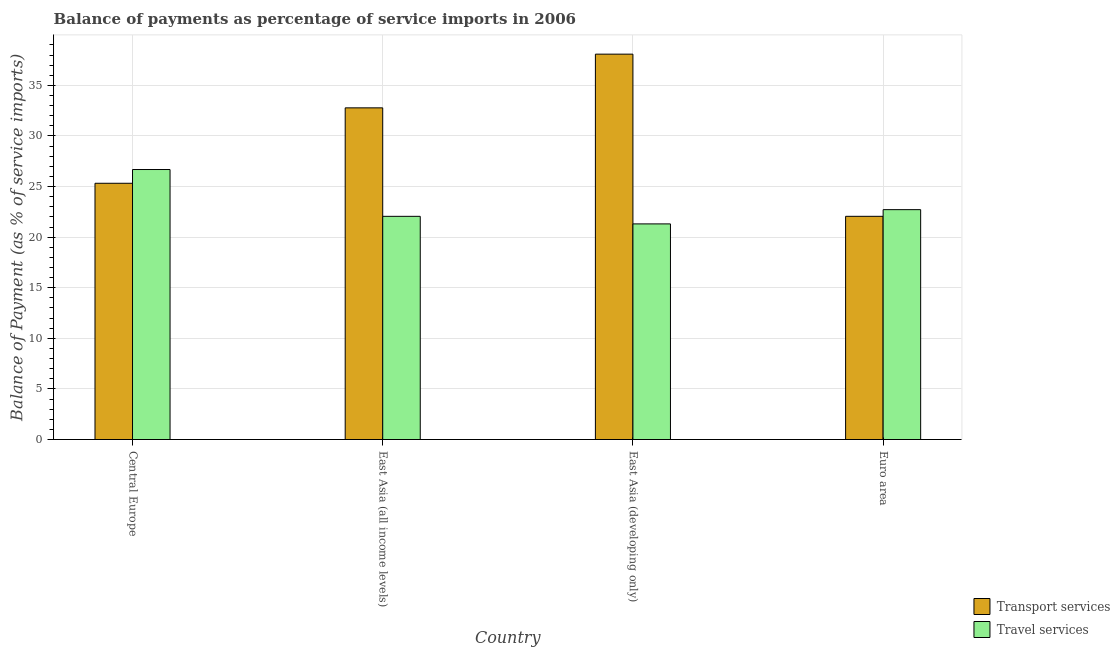Are the number of bars on each tick of the X-axis equal?
Give a very brief answer. Yes. How many bars are there on the 1st tick from the right?
Your answer should be compact. 2. What is the label of the 4th group of bars from the left?
Give a very brief answer. Euro area. In how many cases, is the number of bars for a given country not equal to the number of legend labels?
Offer a terse response. 0. What is the balance of payments of travel services in East Asia (all income levels)?
Give a very brief answer. 22.06. Across all countries, what is the maximum balance of payments of transport services?
Give a very brief answer. 38.09. Across all countries, what is the minimum balance of payments of travel services?
Offer a terse response. 21.31. In which country was the balance of payments of transport services maximum?
Provide a succinct answer. East Asia (developing only). In which country was the balance of payments of travel services minimum?
Ensure brevity in your answer.  East Asia (developing only). What is the total balance of payments of travel services in the graph?
Make the answer very short. 92.77. What is the difference between the balance of payments of transport services in Central Europe and that in Euro area?
Provide a short and direct response. 3.27. What is the difference between the balance of payments of travel services in Euro area and the balance of payments of transport services in Central Europe?
Provide a succinct answer. -2.61. What is the average balance of payments of transport services per country?
Give a very brief answer. 29.56. What is the difference between the balance of payments of transport services and balance of payments of travel services in East Asia (all income levels)?
Your response must be concise. 10.72. What is the ratio of the balance of payments of transport services in Central Europe to that in East Asia (all income levels)?
Give a very brief answer. 0.77. What is the difference between the highest and the second highest balance of payments of transport services?
Give a very brief answer. 5.31. What is the difference between the highest and the lowest balance of payments of transport services?
Keep it short and to the point. 16.03. What does the 2nd bar from the left in East Asia (all income levels) represents?
Make the answer very short. Travel services. What does the 1st bar from the right in East Asia (developing only) represents?
Provide a succinct answer. Travel services. How many bars are there?
Give a very brief answer. 8. How many countries are there in the graph?
Make the answer very short. 4. What is the difference between two consecutive major ticks on the Y-axis?
Keep it short and to the point. 5. How many legend labels are there?
Provide a succinct answer. 2. What is the title of the graph?
Your response must be concise. Balance of payments as percentage of service imports in 2006. Does "Exports" appear as one of the legend labels in the graph?
Your answer should be very brief. No. What is the label or title of the Y-axis?
Make the answer very short. Balance of Payment (as % of service imports). What is the Balance of Payment (as % of service imports) in Transport services in Central Europe?
Your answer should be compact. 25.33. What is the Balance of Payment (as % of service imports) in Travel services in Central Europe?
Your answer should be compact. 26.69. What is the Balance of Payment (as % of service imports) in Transport services in East Asia (all income levels)?
Provide a succinct answer. 32.78. What is the Balance of Payment (as % of service imports) of Travel services in East Asia (all income levels)?
Keep it short and to the point. 22.06. What is the Balance of Payment (as % of service imports) in Transport services in East Asia (developing only)?
Your response must be concise. 38.09. What is the Balance of Payment (as % of service imports) of Travel services in East Asia (developing only)?
Your answer should be very brief. 21.31. What is the Balance of Payment (as % of service imports) of Transport services in Euro area?
Your answer should be very brief. 22.06. What is the Balance of Payment (as % of service imports) in Travel services in Euro area?
Your response must be concise. 22.72. Across all countries, what is the maximum Balance of Payment (as % of service imports) of Transport services?
Your answer should be very brief. 38.09. Across all countries, what is the maximum Balance of Payment (as % of service imports) in Travel services?
Provide a short and direct response. 26.69. Across all countries, what is the minimum Balance of Payment (as % of service imports) of Transport services?
Your answer should be very brief. 22.06. Across all countries, what is the minimum Balance of Payment (as % of service imports) in Travel services?
Your response must be concise. 21.31. What is the total Balance of Payment (as % of service imports) in Transport services in the graph?
Keep it short and to the point. 118.25. What is the total Balance of Payment (as % of service imports) in Travel services in the graph?
Provide a short and direct response. 92.77. What is the difference between the Balance of Payment (as % of service imports) of Transport services in Central Europe and that in East Asia (all income levels)?
Offer a very short reply. -7.45. What is the difference between the Balance of Payment (as % of service imports) of Travel services in Central Europe and that in East Asia (all income levels)?
Your response must be concise. 4.63. What is the difference between the Balance of Payment (as % of service imports) of Transport services in Central Europe and that in East Asia (developing only)?
Keep it short and to the point. -12.76. What is the difference between the Balance of Payment (as % of service imports) in Travel services in Central Europe and that in East Asia (developing only)?
Give a very brief answer. 5.38. What is the difference between the Balance of Payment (as % of service imports) of Transport services in Central Europe and that in Euro area?
Your answer should be very brief. 3.27. What is the difference between the Balance of Payment (as % of service imports) of Travel services in Central Europe and that in Euro area?
Make the answer very short. 3.97. What is the difference between the Balance of Payment (as % of service imports) of Transport services in East Asia (all income levels) and that in East Asia (developing only)?
Offer a very short reply. -5.31. What is the difference between the Balance of Payment (as % of service imports) of Travel services in East Asia (all income levels) and that in East Asia (developing only)?
Keep it short and to the point. 0.75. What is the difference between the Balance of Payment (as % of service imports) of Transport services in East Asia (all income levels) and that in Euro area?
Keep it short and to the point. 10.72. What is the difference between the Balance of Payment (as % of service imports) in Travel services in East Asia (all income levels) and that in Euro area?
Your answer should be compact. -0.66. What is the difference between the Balance of Payment (as % of service imports) in Transport services in East Asia (developing only) and that in Euro area?
Your answer should be compact. 16.03. What is the difference between the Balance of Payment (as % of service imports) in Travel services in East Asia (developing only) and that in Euro area?
Give a very brief answer. -1.41. What is the difference between the Balance of Payment (as % of service imports) of Transport services in Central Europe and the Balance of Payment (as % of service imports) of Travel services in East Asia (all income levels)?
Give a very brief answer. 3.27. What is the difference between the Balance of Payment (as % of service imports) of Transport services in Central Europe and the Balance of Payment (as % of service imports) of Travel services in East Asia (developing only)?
Your answer should be compact. 4.02. What is the difference between the Balance of Payment (as % of service imports) in Transport services in Central Europe and the Balance of Payment (as % of service imports) in Travel services in Euro area?
Your answer should be compact. 2.61. What is the difference between the Balance of Payment (as % of service imports) of Transport services in East Asia (all income levels) and the Balance of Payment (as % of service imports) of Travel services in East Asia (developing only)?
Give a very brief answer. 11.47. What is the difference between the Balance of Payment (as % of service imports) in Transport services in East Asia (all income levels) and the Balance of Payment (as % of service imports) in Travel services in Euro area?
Provide a short and direct response. 10.06. What is the difference between the Balance of Payment (as % of service imports) in Transport services in East Asia (developing only) and the Balance of Payment (as % of service imports) in Travel services in Euro area?
Give a very brief answer. 15.37. What is the average Balance of Payment (as % of service imports) of Transport services per country?
Provide a short and direct response. 29.56. What is the average Balance of Payment (as % of service imports) of Travel services per country?
Your answer should be compact. 23.19. What is the difference between the Balance of Payment (as % of service imports) of Transport services and Balance of Payment (as % of service imports) of Travel services in Central Europe?
Keep it short and to the point. -1.36. What is the difference between the Balance of Payment (as % of service imports) in Transport services and Balance of Payment (as % of service imports) in Travel services in East Asia (all income levels)?
Provide a short and direct response. 10.72. What is the difference between the Balance of Payment (as % of service imports) in Transport services and Balance of Payment (as % of service imports) in Travel services in East Asia (developing only)?
Ensure brevity in your answer.  16.78. What is the difference between the Balance of Payment (as % of service imports) of Transport services and Balance of Payment (as % of service imports) of Travel services in Euro area?
Your answer should be very brief. -0.66. What is the ratio of the Balance of Payment (as % of service imports) in Transport services in Central Europe to that in East Asia (all income levels)?
Your answer should be very brief. 0.77. What is the ratio of the Balance of Payment (as % of service imports) of Travel services in Central Europe to that in East Asia (all income levels)?
Your answer should be compact. 1.21. What is the ratio of the Balance of Payment (as % of service imports) in Transport services in Central Europe to that in East Asia (developing only)?
Provide a succinct answer. 0.66. What is the ratio of the Balance of Payment (as % of service imports) in Travel services in Central Europe to that in East Asia (developing only)?
Your answer should be compact. 1.25. What is the ratio of the Balance of Payment (as % of service imports) of Transport services in Central Europe to that in Euro area?
Your answer should be compact. 1.15. What is the ratio of the Balance of Payment (as % of service imports) of Travel services in Central Europe to that in Euro area?
Ensure brevity in your answer.  1.17. What is the ratio of the Balance of Payment (as % of service imports) of Transport services in East Asia (all income levels) to that in East Asia (developing only)?
Keep it short and to the point. 0.86. What is the ratio of the Balance of Payment (as % of service imports) in Travel services in East Asia (all income levels) to that in East Asia (developing only)?
Ensure brevity in your answer.  1.04. What is the ratio of the Balance of Payment (as % of service imports) in Transport services in East Asia (all income levels) to that in Euro area?
Give a very brief answer. 1.49. What is the ratio of the Balance of Payment (as % of service imports) of Transport services in East Asia (developing only) to that in Euro area?
Your answer should be compact. 1.73. What is the ratio of the Balance of Payment (as % of service imports) in Travel services in East Asia (developing only) to that in Euro area?
Provide a succinct answer. 0.94. What is the difference between the highest and the second highest Balance of Payment (as % of service imports) of Transport services?
Your answer should be compact. 5.31. What is the difference between the highest and the second highest Balance of Payment (as % of service imports) in Travel services?
Offer a terse response. 3.97. What is the difference between the highest and the lowest Balance of Payment (as % of service imports) in Transport services?
Your answer should be compact. 16.03. What is the difference between the highest and the lowest Balance of Payment (as % of service imports) in Travel services?
Your answer should be very brief. 5.38. 